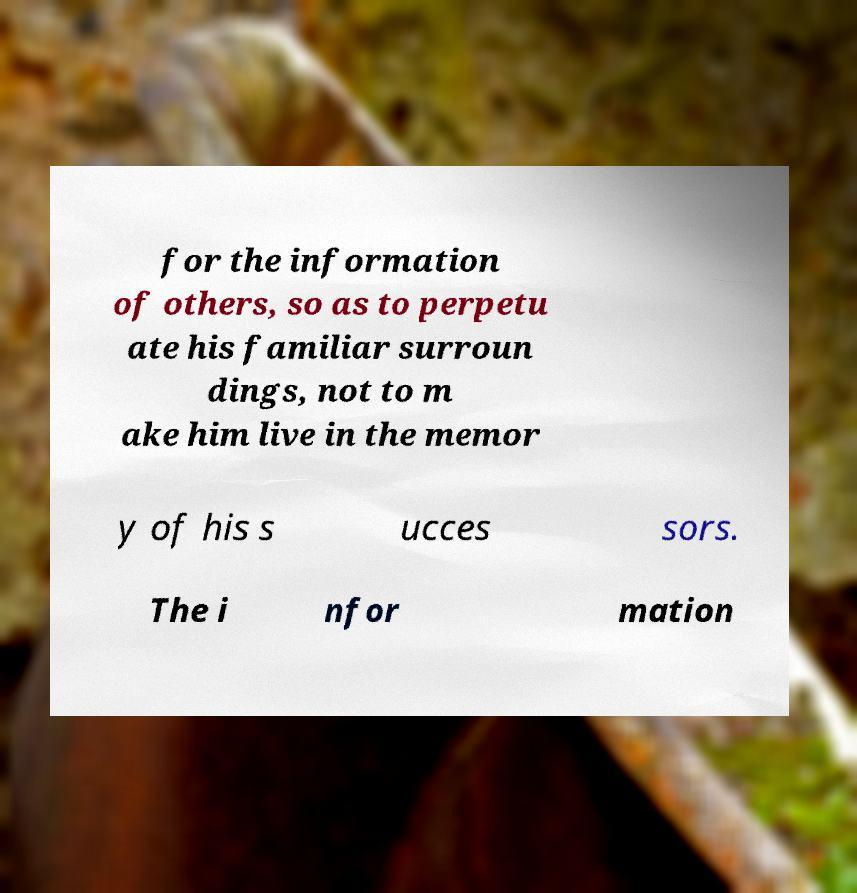Can you accurately transcribe the text from the provided image for me? for the information of others, so as to perpetu ate his familiar surroun dings, not to m ake him live in the memor y of his s ucces sors. The i nfor mation 